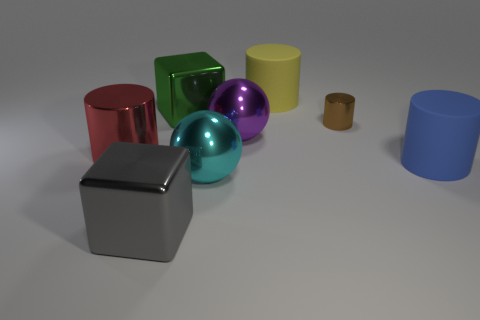There is another small cylinder that is the same material as the red cylinder; what is its color?
Keep it short and to the point. Brown. Is the color of the matte object behind the big purple thing the same as the tiny shiny cylinder?
Provide a short and direct response. No. There is a big cylinder behind the tiny cylinder; what is it made of?
Give a very brief answer. Rubber. Is the number of large blue matte things that are in front of the gray thing the same as the number of big cyan rubber cubes?
Your answer should be very brief. Yes. How many large metallic cylinders have the same color as the small metallic thing?
Give a very brief answer. 0. What color is the other tiny object that is the same shape as the red shiny object?
Your answer should be very brief. Brown. Is the size of the purple metal thing the same as the blue cylinder?
Give a very brief answer. Yes. Are there an equal number of yellow matte cylinders to the left of the yellow object and rubber cylinders that are behind the blue cylinder?
Offer a very short reply. No. Are any red objects visible?
Offer a terse response. Yes. What size is the other thing that is the same shape as the large cyan object?
Your answer should be compact. Large. 